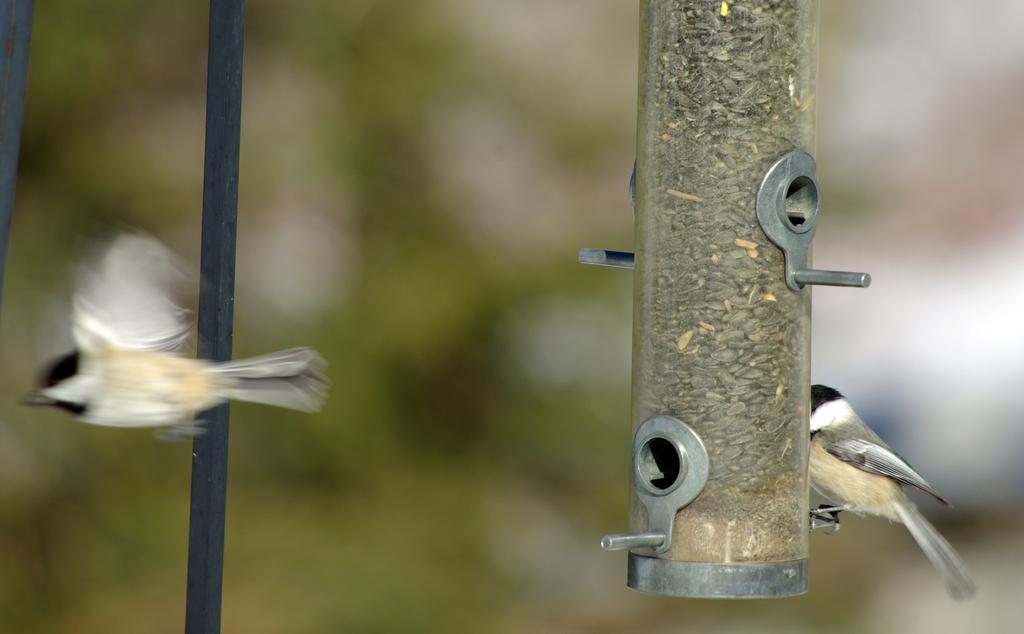In one or two sentences, can you explain what this image depicts? In this image on the right side we can see a bird on a bird feeder. On the left side there is a bird flying in the air and there are rods. In the background the image is blur. 